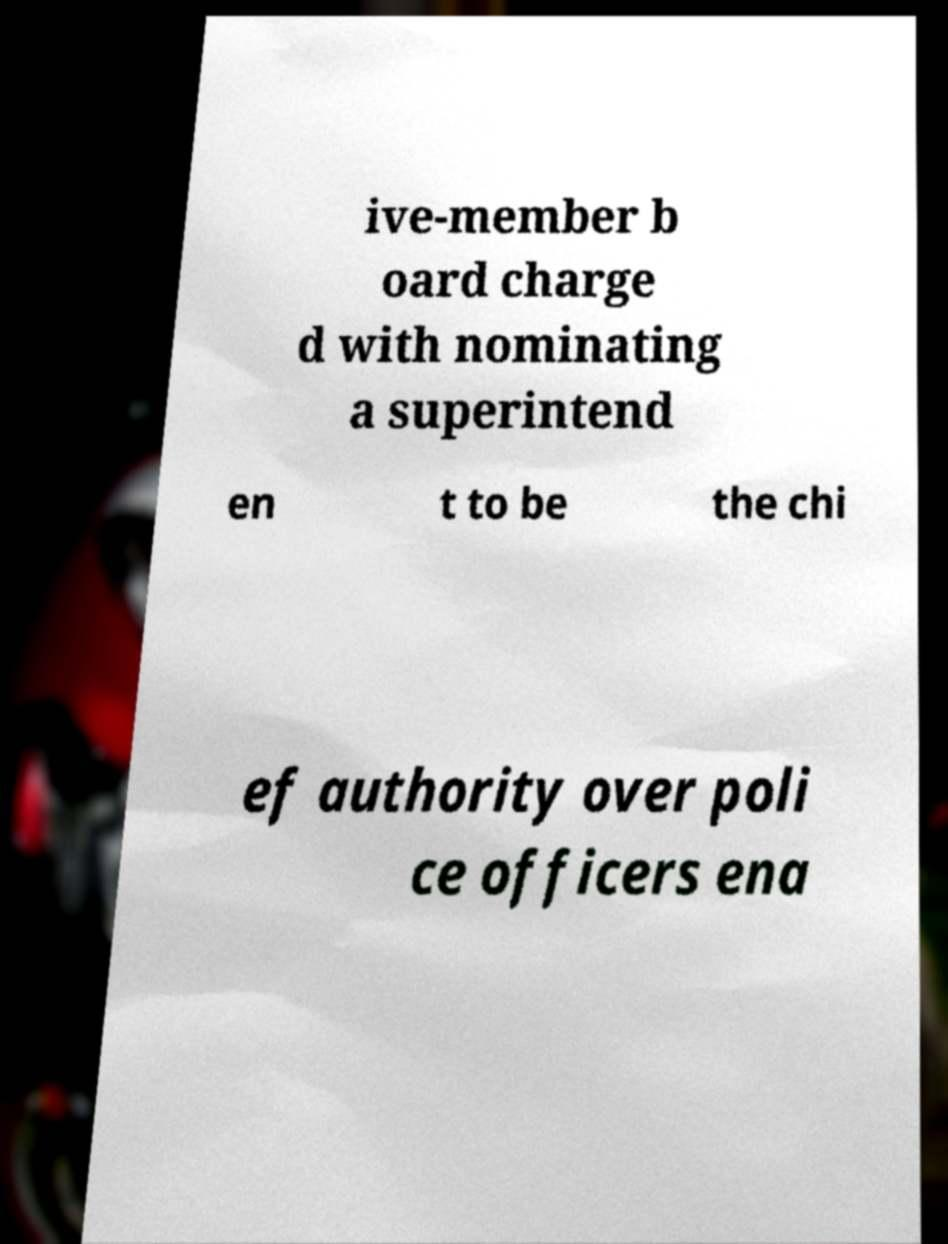I need the written content from this picture converted into text. Can you do that? ive-member b oard charge d with nominating a superintend en t to be the chi ef authority over poli ce officers ena 